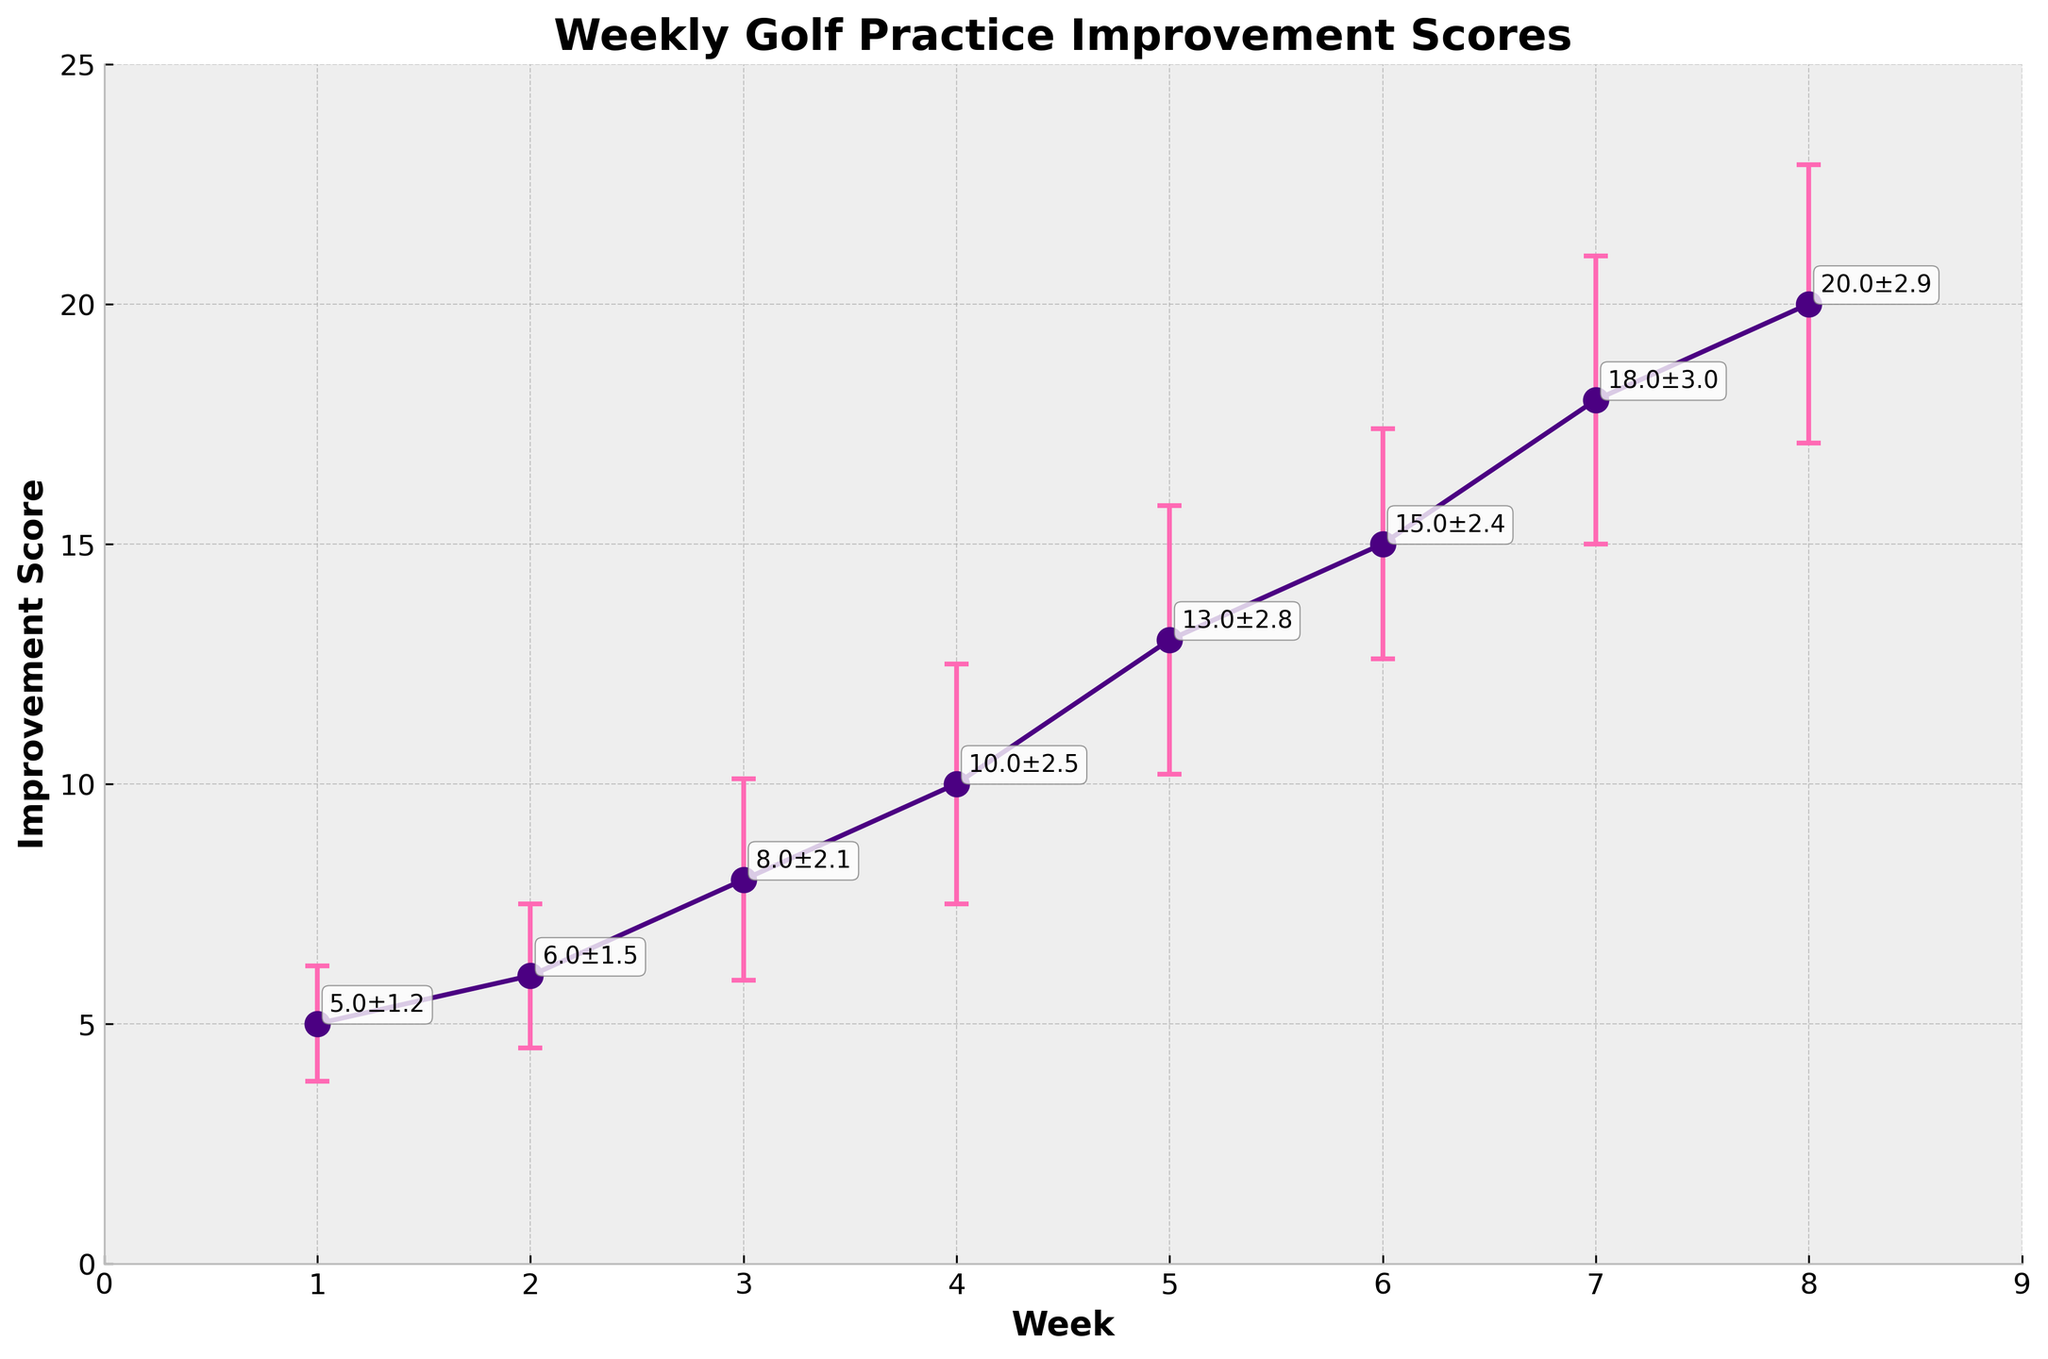what is the title of the figure? The title is usually displayed at the top of the figure. In this case, it reads "Weekly Golf Practice Improvement Scores".
Answer: Weekly Golf Practice Improvement Scores How many weeks are displayed on the x-axis? On the x-axis, the data points are marked as weeks. By counting them, we see they range from 1 to 8.
Answer: 8 What is the improvement score in week 4? The improvement score for week 4 is displayed on the y-axis corresponding to the week 4 data point. The annotated value provides a clearer view. It's 10.
Answer: 10 How does the average improvement score from week 1 to week 4 compare to that of week 5 to week 8? To find this, we need the scores of the weeks: (5+6+8+10)/4 for weeks 1-4 and (13+15+18+20)/4 for weeks 5-8. Comparing these averages, (5+6+8+10)/4 = 7.25 and (13+15+18+20)/4 = 16.5.
Answer: The average score for weeks 1-4 is 7.25; for weeks 5-8, it is 16.5 In which week is the improvement score the highest and what is this score? By observing the y-axis and the plot, week 8 has the highest point. The annotated number next to week 8 indicates the score which is 20.
Answer: Week 8, score 20 What is the range of improvement scores from week 1 to week 8? The range is found by subtracting the minimum score from the maximum score among the weeks. The scores range from 5 to 20. The range is 20 - 5.
Answer: 15 What is the maximum standard deviation shown on the chart, and in which week does it occur? The error bars represent the standard deviation. The largest error bar is in week 7 with a value of 3.0.
Answer: Week 7, 3.0 How consistent are the improvement scores based on the error bars from week 1 to week 8? By looking at the error bars, we notice their length varies, indicating variability. Weeks 1-6 have shorter error bars compared to weeks 7 and 8, indicating more variability in the latter weeks.
Answer: Less consistent, greater variability in weeks 7 and 8 Compare the improvement score and standard deviation of week 4 to week 6. Which week shows better performance? Week 4 has an improvement score of 10 and a standard deviation of 2.5. Week 6 has a score of 15 with a standard deviation of 2.4. Week 6 shows better performance with higher improvement and slightly lower variability.
Answer: Week 6, better performance What can be said about the trend of the improvement scores over the weeks? Observing the line connecting the data points from weeks 1 to 8, the scores steadily increase, indicating an overall improvement trend.
Answer: Increasing trend 